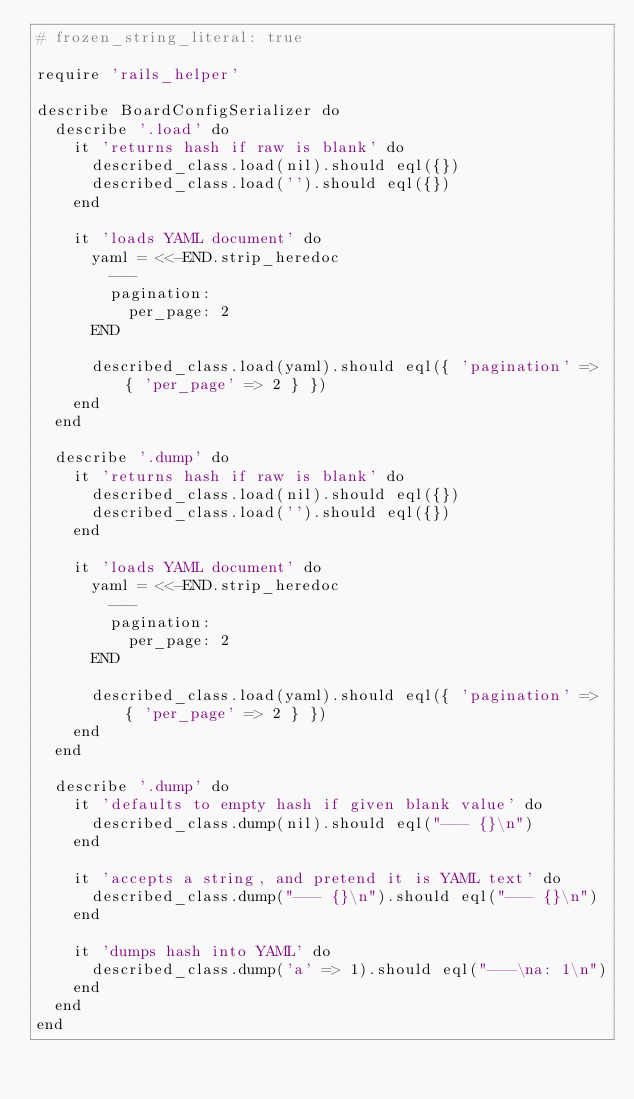Convert code to text. <code><loc_0><loc_0><loc_500><loc_500><_Ruby_># frozen_string_literal: true

require 'rails_helper'

describe BoardConfigSerializer do
  describe '.load' do
    it 'returns hash if raw is blank' do
      described_class.load(nil).should eql({})
      described_class.load('').should eql({})
    end

    it 'loads YAML document' do
      yaml = <<-END.strip_heredoc
        ---
        pagination:
          per_page: 2
      END

      described_class.load(yaml).should eql({ 'pagination' => { 'per_page' => 2 } })
    end
  end

  describe '.dump' do
    it 'returns hash if raw is blank' do
      described_class.load(nil).should eql({})
      described_class.load('').should eql({})
    end

    it 'loads YAML document' do
      yaml = <<-END.strip_heredoc
        ---
        pagination:
          per_page: 2
      END

      described_class.load(yaml).should eql({ 'pagination' => { 'per_page' => 2 } })
    end
  end

  describe '.dump' do
    it 'defaults to empty hash if given blank value' do
      described_class.dump(nil).should eql("--- {}\n")
    end

    it 'accepts a string, and pretend it is YAML text' do
      described_class.dump("--- {}\n").should eql("--- {}\n")
    end

    it 'dumps hash into YAML' do
      described_class.dump('a' => 1).should eql("---\na: 1\n")
    end
  end
end
</code> 